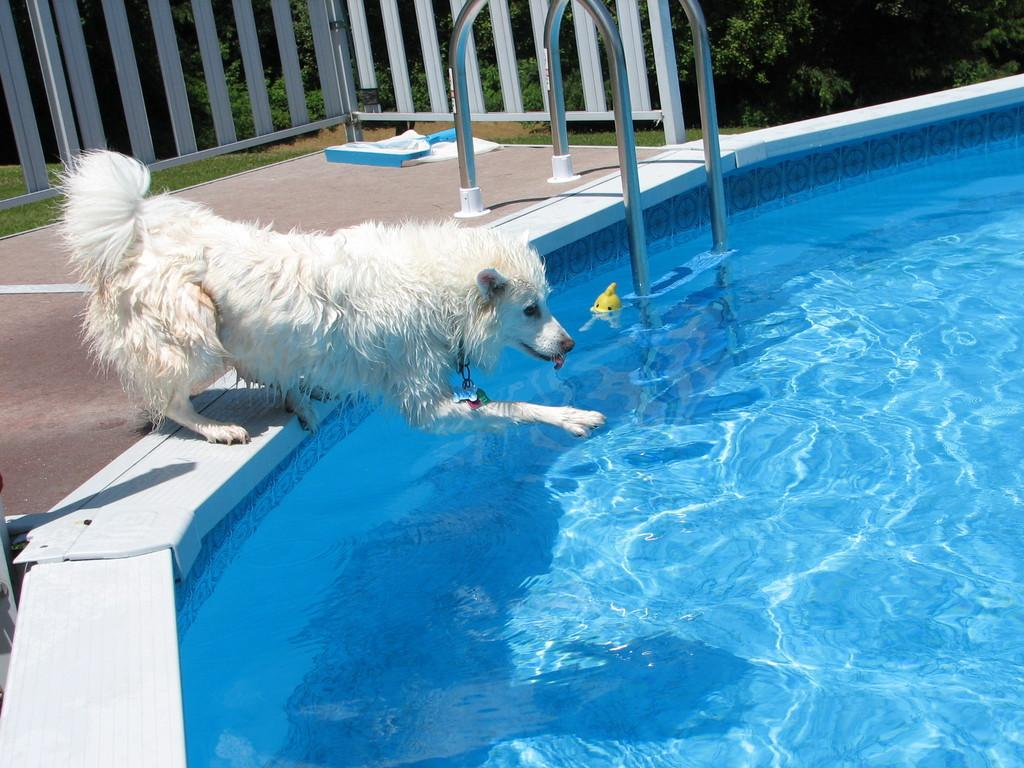What type of animal is in the image? There is a dog in the image. What color is the dog? The dog is white. What is visible in the image besides the dog? There is water visible in the image. What can be seen in the background of the image? There is railing and green plants in the background of the image. What type of hat is the dog wearing in the image? There is no hat present in the image; the dog is not wearing any clothing or accessories. 